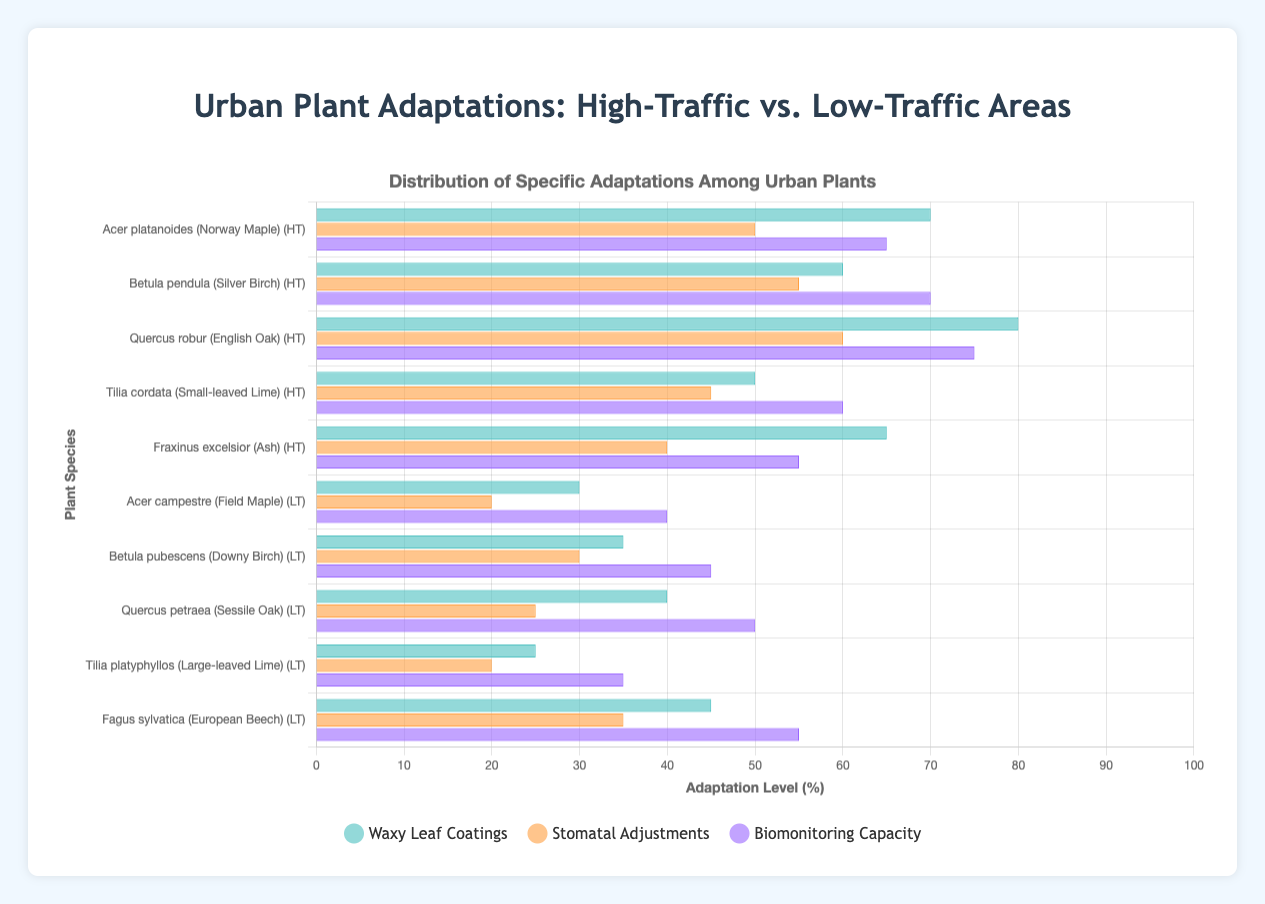Which plant species in high-traffic areas has the highest level of waxy leaf coatings? By identifying the species in high-traffic areas and comparing their waxy leaf coating values, we find that Quercus robur (English Oak) has the highest value of 80%
Answer: Quercus robur (English Oak) Which adaptation is generally higher in high-traffic areas compared to low-traffic areas? Comparing the average levels of waxy leaf coatings, stomatal adjustments, and biomonitoring capacity in both traffic conditions, all adaptations are generally higher in high-traffic areas, but waxy leaf coatings stand out the most with the overall highest values
Answer: Waxy Leaf Coatings What is the difference in stomatal adjustments between Acer platanoides (Norway Maple) in high-traffic areas and Betula pubescens (Downy Birch) in low-traffic areas? Acer platanoides (Norway Maple) in high-traffic areas has 50% stomatal adjustments while Betula pubescens (Downy Birch) in low-traffic areas has 30%. The difference is 50% - 30% = 20%
Answer: 20% Which species in low-traffic areas has the highest biomonitoring capacity? Among low-traffic area species, by checking their biomonitoring capacities, Fagus sylvatica (European Beech) has the highest value at 55%
Answer: Fagus sylvatica (European Beech) Is the waxy leaf coating of Tilia cordata (Small-leaved Lime) in high-traffic areas greater than the biomonitoring capacity of Tilia platyphyllos (Large-leaved Lime) in low-traffic areas? Checking the values, Tilia cordata (Small-leaved Lime) in high-traffic areas has a waxy leaf coating of 50%, while Tilia platyphyllos (Large-leaved Lime) in low-traffic areas has a biomonitoring capacity of 35%. Therefore, 50% is greater than 35%
Answer: Yes What is the sum of the biomonitoring capacities of all species in high-traffic areas? Adding the biomonitoring capacities of all high-traffic species: 65 + 70 + 75 + 60 + 55 = 325
Answer: 325 Which adaptation attribute (waxy leaf coatings, stomatal adjustments, biomonitoring capacity) is visually represented in green bars? From the legend under the chart, green-colored bars represent waxy leaf coatings
Answer: Waxy Leaf Coatings How much higher is the average waxy leaf coating in high-traffic areas compared to low-traffic areas? The average waxy leaf coatings in high-traffic areas are (70 + 60 + 80 + 50 + 65) / 5 = 65% and in low-traffic areas are (30 + 35 + 40 + 25 + 45) / 5 = 35%. The difference is 65% - 35% = 30%
Answer: 30% Which has a higher average stomatal adjustment, high-traffic or low-traffic area species? The averages are calculated as follows: high-traffic stomatal adjustments = (50 + 55 + 60 + 45 + 40) / 5 = 50%, low-traffic stomatal adjustments = (20 + 30 + 25 + 20 + 35) / 5 = 26%. Therefore, high-traffic species have a higher average
Answer: High-Traffic Area Species Which species shows the largest difference in biomonitoring capacity between high-traffic and low-traffic areas? By calculating differences in biomonitoring capacity for each species: 
1. Acer: (65 - 40) = 25
2. Betula: (70 - 45) = 25
3. Quercus: (75 - 50) = 25
4. Tilia: (60 - 35) = 25
5. Fraxinus/Fagus: While Fraxinus excelsior is not in low-traffic and Fagus sylvatica is not in high-traffic, we disregard them for direct comparison.
They all have the largest difference of 25%
Answer: All species at 25% 